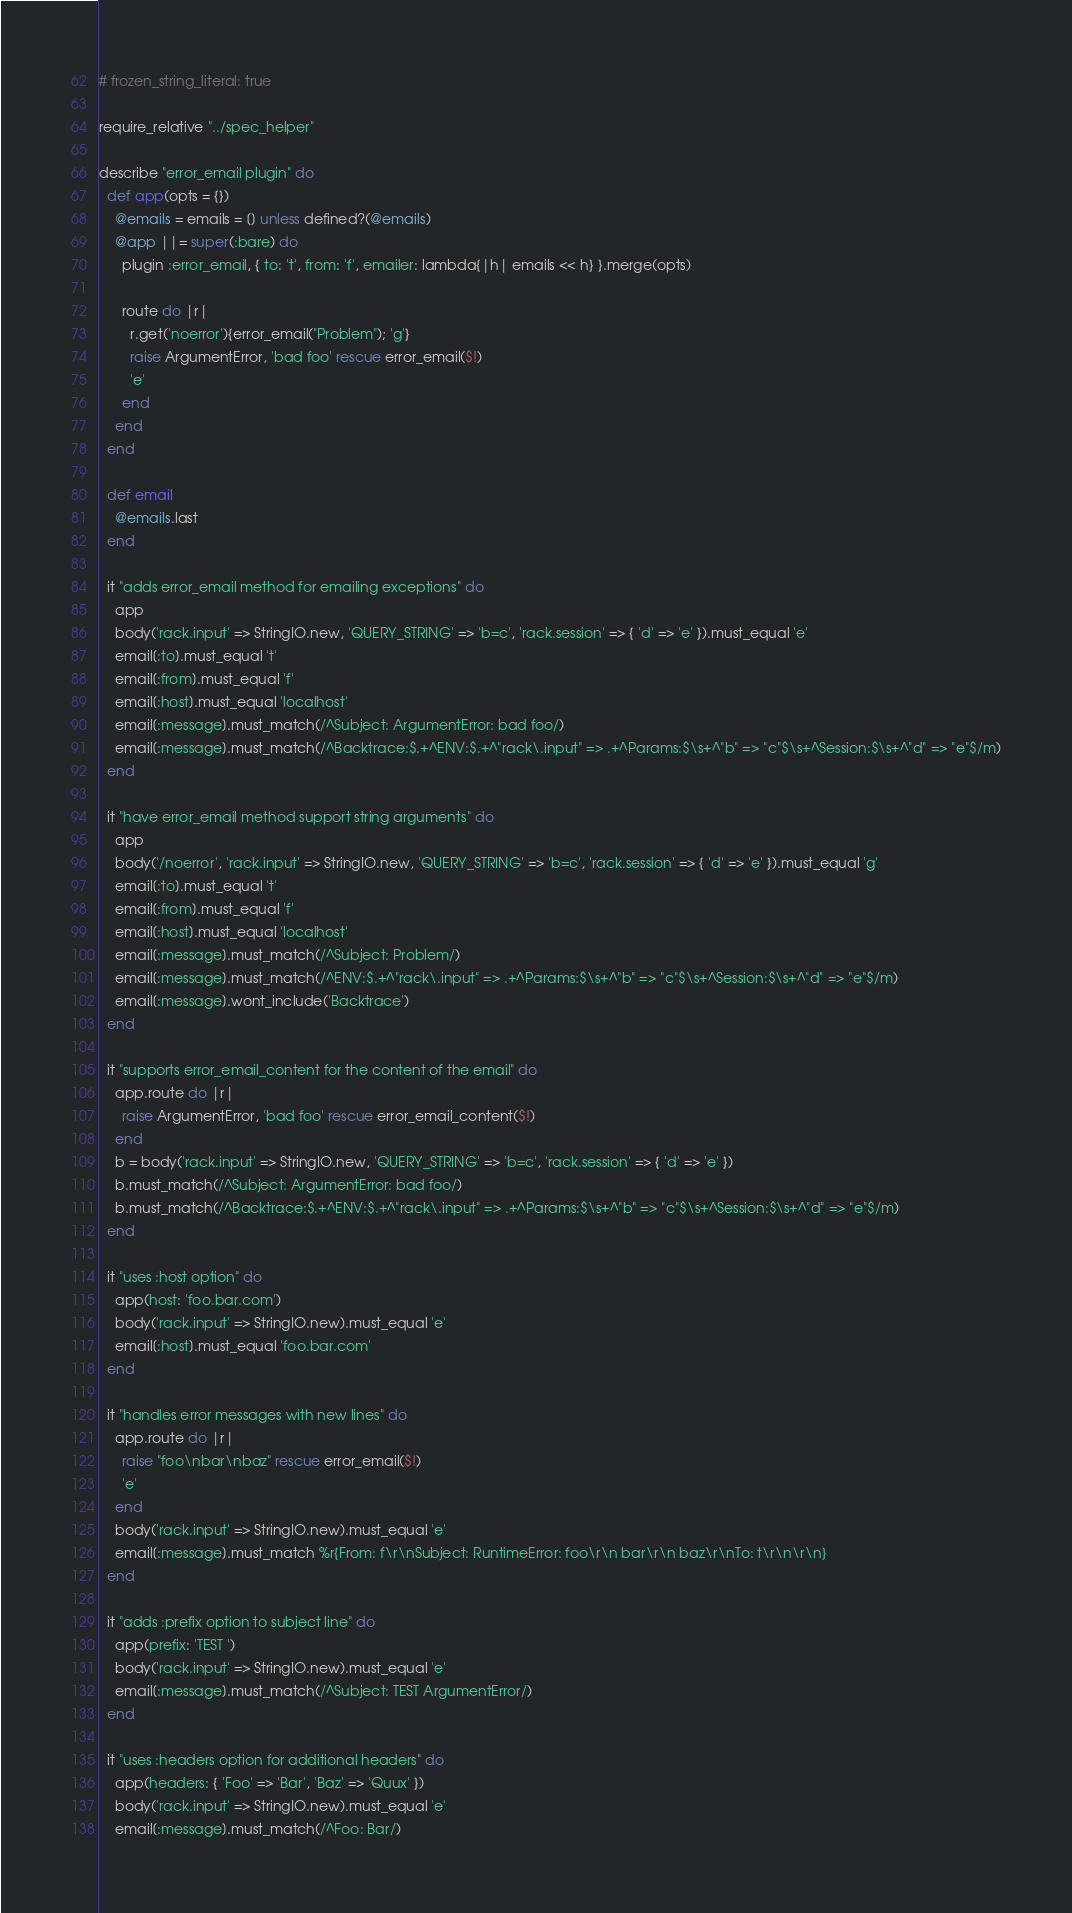<code> <loc_0><loc_0><loc_500><loc_500><_Ruby_># frozen_string_literal: true

require_relative "../spec_helper"

describe "error_email plugin" do
  def app(opts = {})
    @emails = emails = [] unless defined?(@emails)
    @app ||= super(:bare) do
      plugin :error_email, { to: 't', from: 'f', emailer: lambda{|h| emails << h} }.merge(opts)

      route do |r|
        r.get('noerror'){error_email("Problem"); 'g'}
        raise ArgumentError, 'bad foo' rescue error_email($!)
        'e'
      end
    end
  end

  def email
    @emails.last
  end

  it "adds error_email method for emailing exceptions" do
    app
    body('rack.input' => StringIO.new, 'QUERY_STRING' => 'b=c', 'rack.session' => { 'd' => 'e' }).must_equal 'e'
    email[:to].must_equal 't'
    email[:from].must_equal 'f'
    email[:host].must_equal 'localhost'
    email[:message].must_match(/^Subject: ArgumentError: bad foo/)
    email[:message].must_match(/^Backtrace:$.+^ENV:$.+^"rack\.input" => .+^Params:$\s+^"b" => "c"$\s+^Session:$\s+^"d" => "e"$/m)
  end

  it "have error_email method support string arguments" do
    app
    body('/noerror', 'rack.input' => StringIO.new, 'QUERY_STRING' => 'b=c', 'rack.session' => { 'd' => 'e' }).must_equal 'g'
    email[:to].must_equal 't'
    email[:from].must_equal 'f'
    email[:host].must_equal 'localhost'
    email[:message].must_match(/^Subject: Problem/)
    email[:message].must_match(/^ENV:$.+^"rack\.input" => .+^Params:$\s+^"b" => "c"$\s+^Session:$\s+^"d" => "e"$/m)
    email[:message].wont_include('Backtrace')
  end

  it "supports error_email_content for the content of the email" do
    app.route do |r|
      raise ArgumentError, 'bad foo' rescue error_email_content($!)
    end
    b = body('rack.input' => StringIO.new, 'QUERY_STRING' => 'b=c', 'rack.session' => { 'd' => 'e' })
    b.must_match(/^Subject: ArgumentError: bad foo/)
    b.must_match(/^Backtrace:$.+^ENV:$.+^"rack\.input" => .+^Params:$\s+^"b" => "c"$\s+^Session:$\s+^"d" => "e"$/m)
  end

  it "uses :host option" do
    app(host: 'foo.bar.com')
    body('rack.input' => StringIO.new).must_equal 'e'
    email[:host].must_equal 'foo.bar.com'
  end

  it "handles error messages with new lines" do
    app.route do |r|
      raise "foo\nbar\nbaz" rescue error_email($!)
      'e'
    end
    body('rack.input' => StringIO.new).must_equal 'e'
    email[:message].must_match %r{From: f\r\nSubject: RuntimeError: foo\r\n bar\r\n baz\r\nTo: t\r\n\r\n}
  end

  it "adds :prefix option to subject line" do
    app(prefix: 'TEST ')
    body('rack.input' => StringIO.new).must_equal 'e'
    email[:message].must_match(/^Subject: TEST ArgumentError/)
  end

  it "uses :headers option for additional headers" do
    app(headers: { 'Foo' => 'Bar', 'Baz' => 'Quux' })
    body('rack.input' => StringIO.new).must_equal 'e'
    email[:message].must_match(/^Foo: Bar/)</code> 